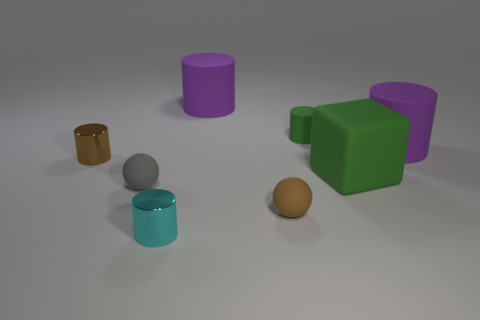Are the small green thing and the tiny cyan cylinder made of the same material?
Make the answer very short. No. There is a shiny object that is the same size as the cyan cylinder; what color is it?
Make the answer very short. Brown. Is the number of large purple cylinders that are right of the matte cube the same as the number of cubes that are behind the small green cylinder?
Make the answer very short. No. There is a green thing in front of the large purple rubber cylinder right of the large matte block; what is it made of?
Provide a succinct answer. Rubber. How many objects are either large rubber things or big red blocks?
Provide a short and direct response. 3. There is a thing that is the same color as the tiny rubber cylinder; what size is it?
Keep it short and to the point. Large. Is the number of small green cylinders less than the number of yellow rubber blocks?
Your answer should be very brief. No. What size is the gray object that is made of the same material as the brown sphere?
Provide a succinct answer. Small. The brown cylinder is what size?
Your response must be concise. Small. What is the shape of the tiny cyan shiny object?
Provide a short and direct response. Cylinder. 